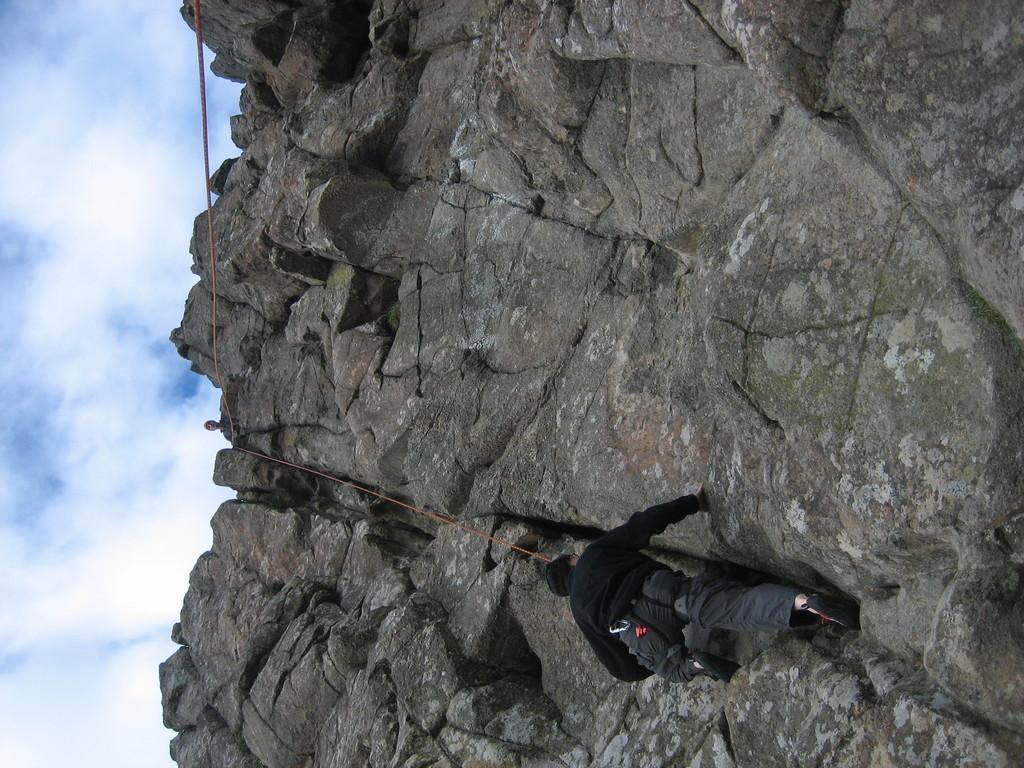What is the person in the image doing? The person in the image is trekking. Where is the person trekking? The person is trekking on a rocky mountain. What tool is the person using while trekking? The person is using a rope while trekking. Can you describe the other person in the image? There is another person standing on top of the mountain. What is visible in the sky in the image? There are clouds visible in the sky. How many screws are visible in the image? There are no screws present in the image. What type of parcel is being delivered by the person trekking in the image? There is no parcel being delivered in the image; the person is trekking on a rocky mountain. 